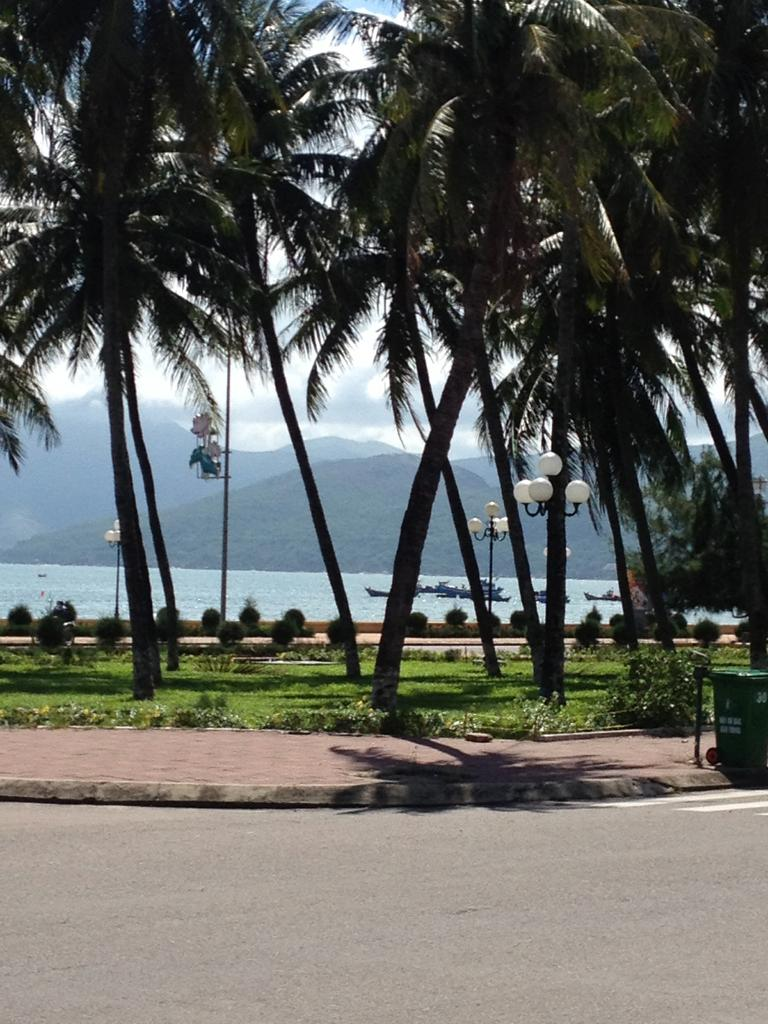What type of natural elements can be seen in the image? There are trees and hills in the image. What man-made structures are present in the image? There are light poles and a bin in the image. What type of vegetation can be seen in the image? There are plants in the image. What is on the water in the image? There are boats on the water in the image. What is at the bottom of the image? There is a road at the bottom of the image. What type of pie is being served on the table in the image? There is no table or pie present in the image. Can you describe the color and texture of the rose in the image? There is no rose present in the image. How many frogs can be seen hopping on the road in the image? There are no frogs present in the image. 